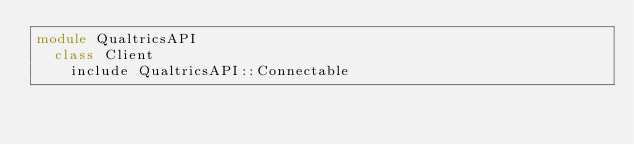<code> <loc_0><loc_0><loc_500><loc_500><_Ruby_>module QualtricsAPI
  class Client
    include QualtricsAPI::Connectable
</code> 